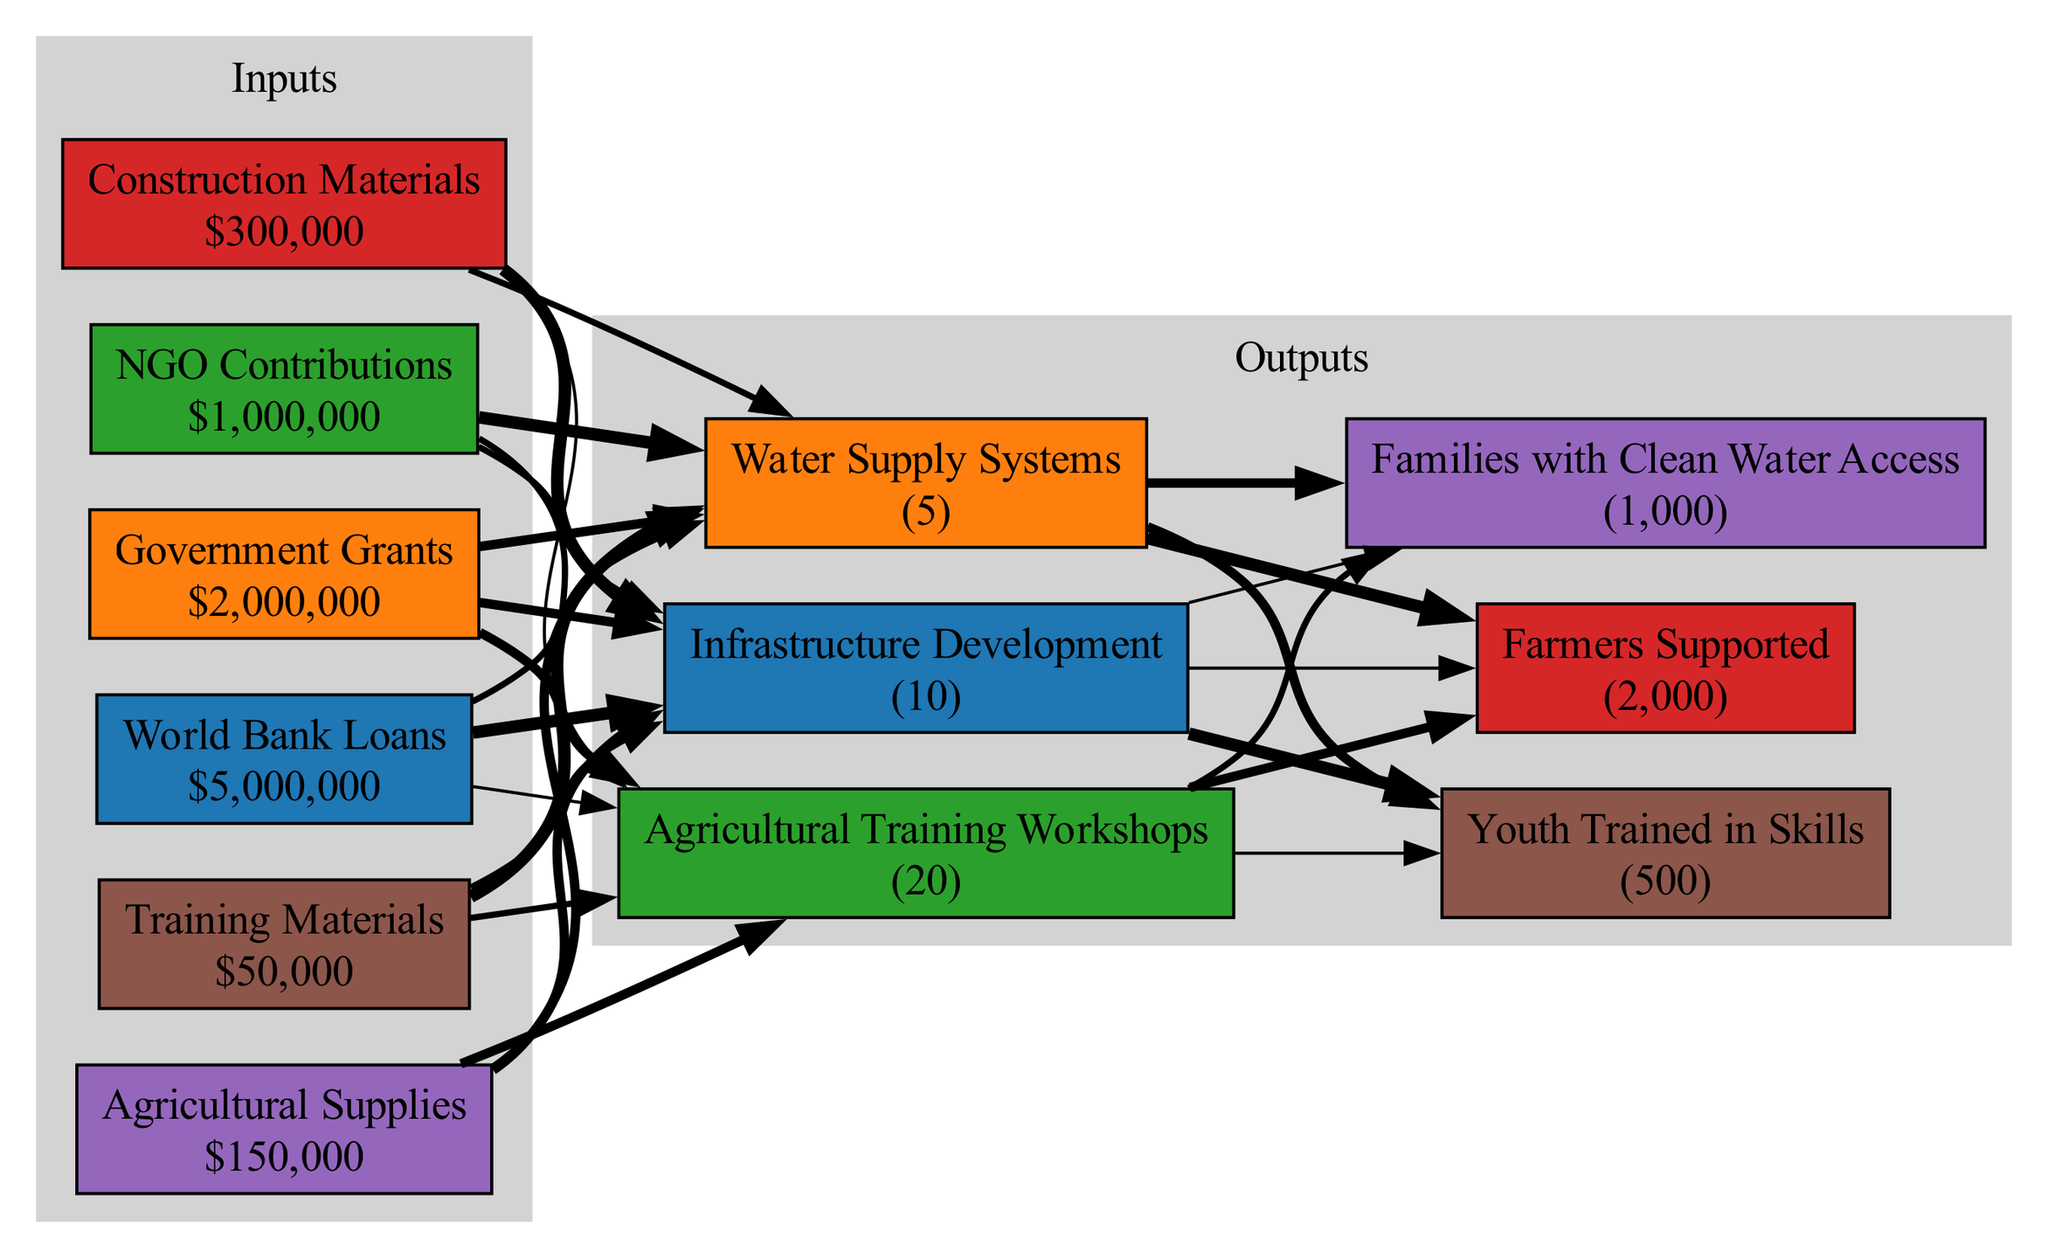What is the total funding from the World Bank Loans? The node labeled "World Bank Loans" shows the amount of funding provided, which is $5,000,000.
Answer: $5,000,000 How many infrastructure development projects were completed? The node labeled "Infrastructure Development" indicates that 10 projects were completed.
Answer: 10 Which material has the highest value? The "Construction Materials" node displays a value of $300,000, which is higher than the others.
Answer: Construction Materials What is the total number of beneficiaries reached? The nodes for beneficiaries show 2000 + 1000 + 500, totaling to 3500 beneficiaries reached.
Answer: 3500 Which funding source has the lowest amount? The "NGO Contributions" node shows the funding amount of $1,000,000, which is the least among the funding sources.
Answer: NGO Contributions How many agricultural training workshops were completed compared to water supply systems? "Agricultural Training Workshops" shows 20 completed projects, while "Water Supply Systems" shows 5, hence 20 is greater than 5.
Answer: 20 What can be inferred about the flow from materials to projects? All materials contribute to the completion of various projects, with their specific edges showing connections to projects completed. This demonstrates resource utilization across different outputs.
Answer: Various projects Which outputs reached the most beneficiaries? The node labeled "Farmers Supported" indicates 2000, which is the highest among the output categories.
Answer: Farmers Supported How many nodes represent funding sources? There are three nodes indicating different funding sources: "World Bank Loans," "Government Grants," and "NGO Contributions."
Answer: 3 